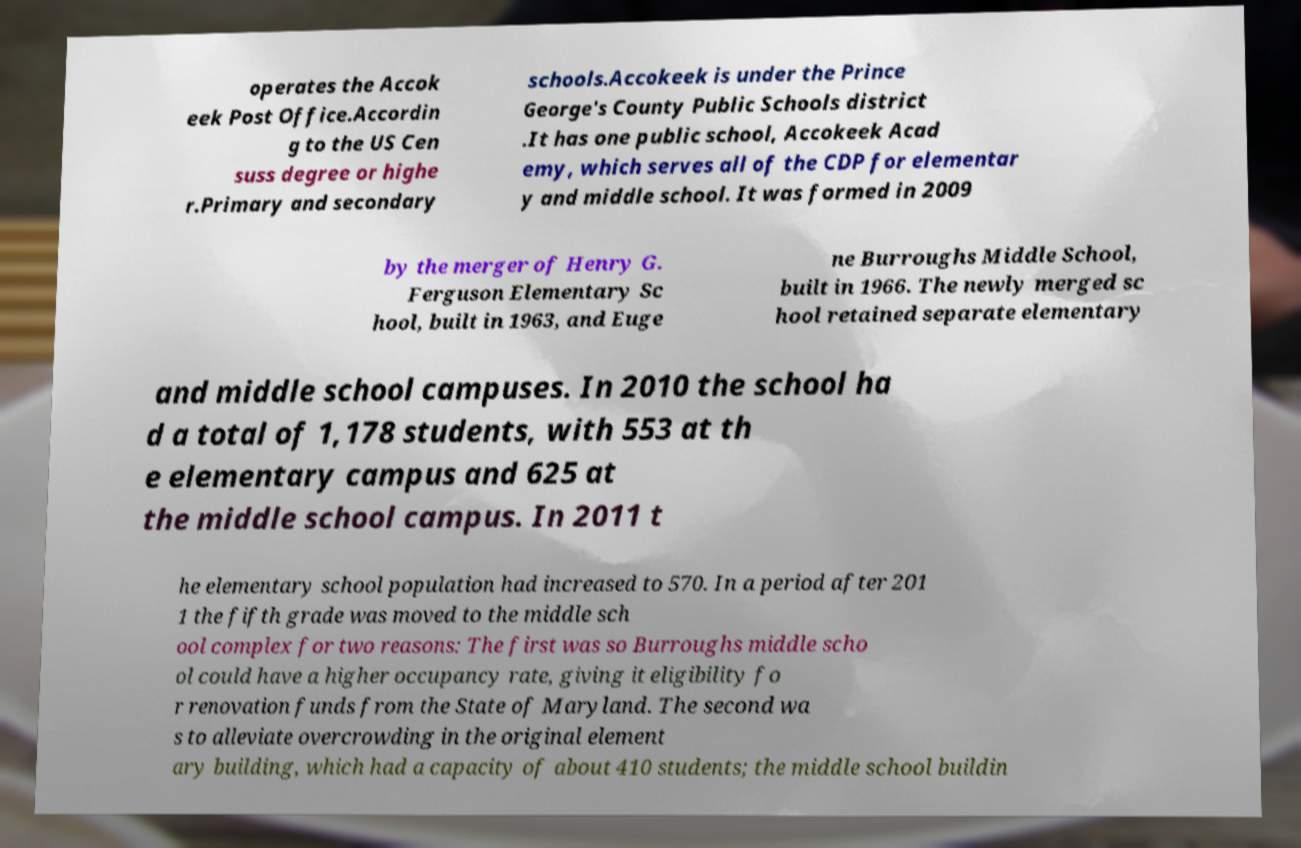Can you accurately transcribe the text from the provided image for me? operates the Accok eek Post Office.Accordin g to the US Cen suss degree or highe r.Primary and secondary schools.Accokeek is under the Prince George's County Public Schools district .It has one public school, Accokeek Acad emy, which serves all of the CDP for elementar y and middle school. It was formed in 2009 by the merger of Henry G. Ferguson Elementary Sc hool, built in 1963, and Euge ne Burroughs Middle School, built in 1966. The newly merged sc hool retained separate elementary and middle school campuses. In 2010 the school ha d a total of 1,178 students, with 553 at th e elementary campus and 625 at the middle school campus. In 2011 t he elementary school population had increased to 570. In a period after 201 1 the fifth grade was moved to the middle sch ool complex for two reasons: The first was so Burroughs middle scho ol could have a higher occupancy rate, giving it eligibility fo r renovation funds from the State of Maryland. The second wa s to alleviate overcrowding in the original element ary building, which had a capacity of about 410 students; the middle school buildin 